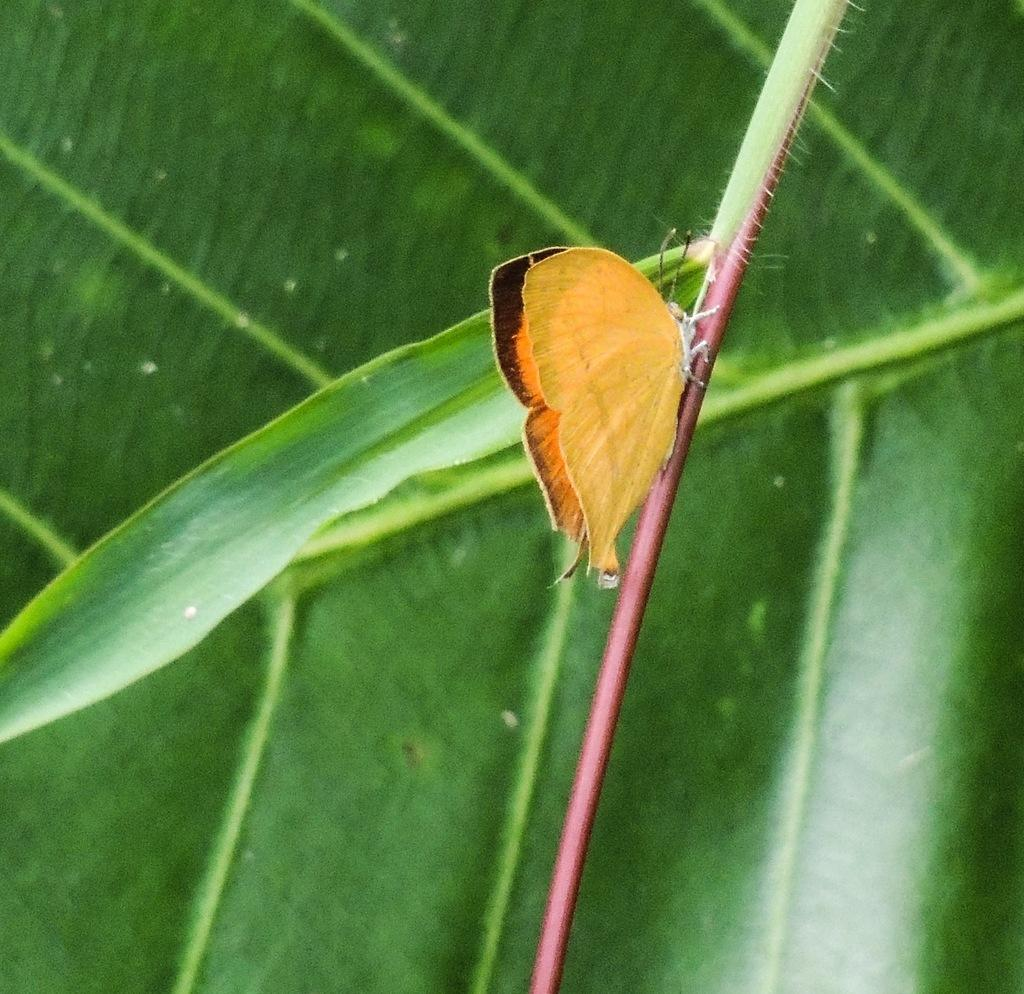What type of vegetation can be seen in the image? There are green color leaves in the image. What animal is present in the image? There is a butterfly in the image. Can you describe the color pattern of the butterfly? The butterfly has a yellow and black color pattern. What type of sound does the fork make in the image? There is no fork present in the image, so it cannot make any sound. 